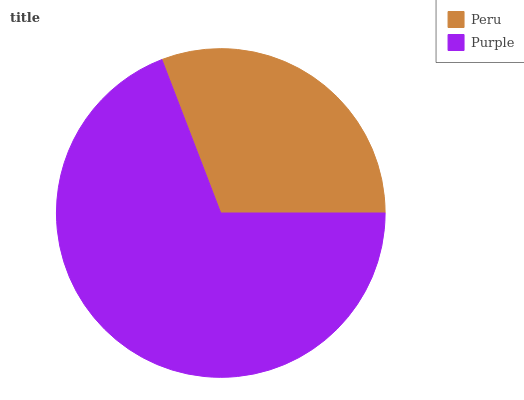Is Peru the minimum?
Answer yes or no. Yes. Is Purple the maximum?
Answer yes or no. Yes. Is Purple the minimum?
Answer yes or no. No. Is Purple greater than Peru?
Answer yes or no. Yes. Is Peru less than Purple?
Answer yes or no. Yes. Is Peru greater than Purple?
Answer yes or no. No. Is Purple less than Peru?
Answer yes or no. No. Is Purple the high median?
Answer yes or no. Yes. Is Peru the low median?
Answer yes or no. Yes. Is Peru the high median?
Answer yes or no. No. Is Purple the low median?
Answer yes or no. No. 